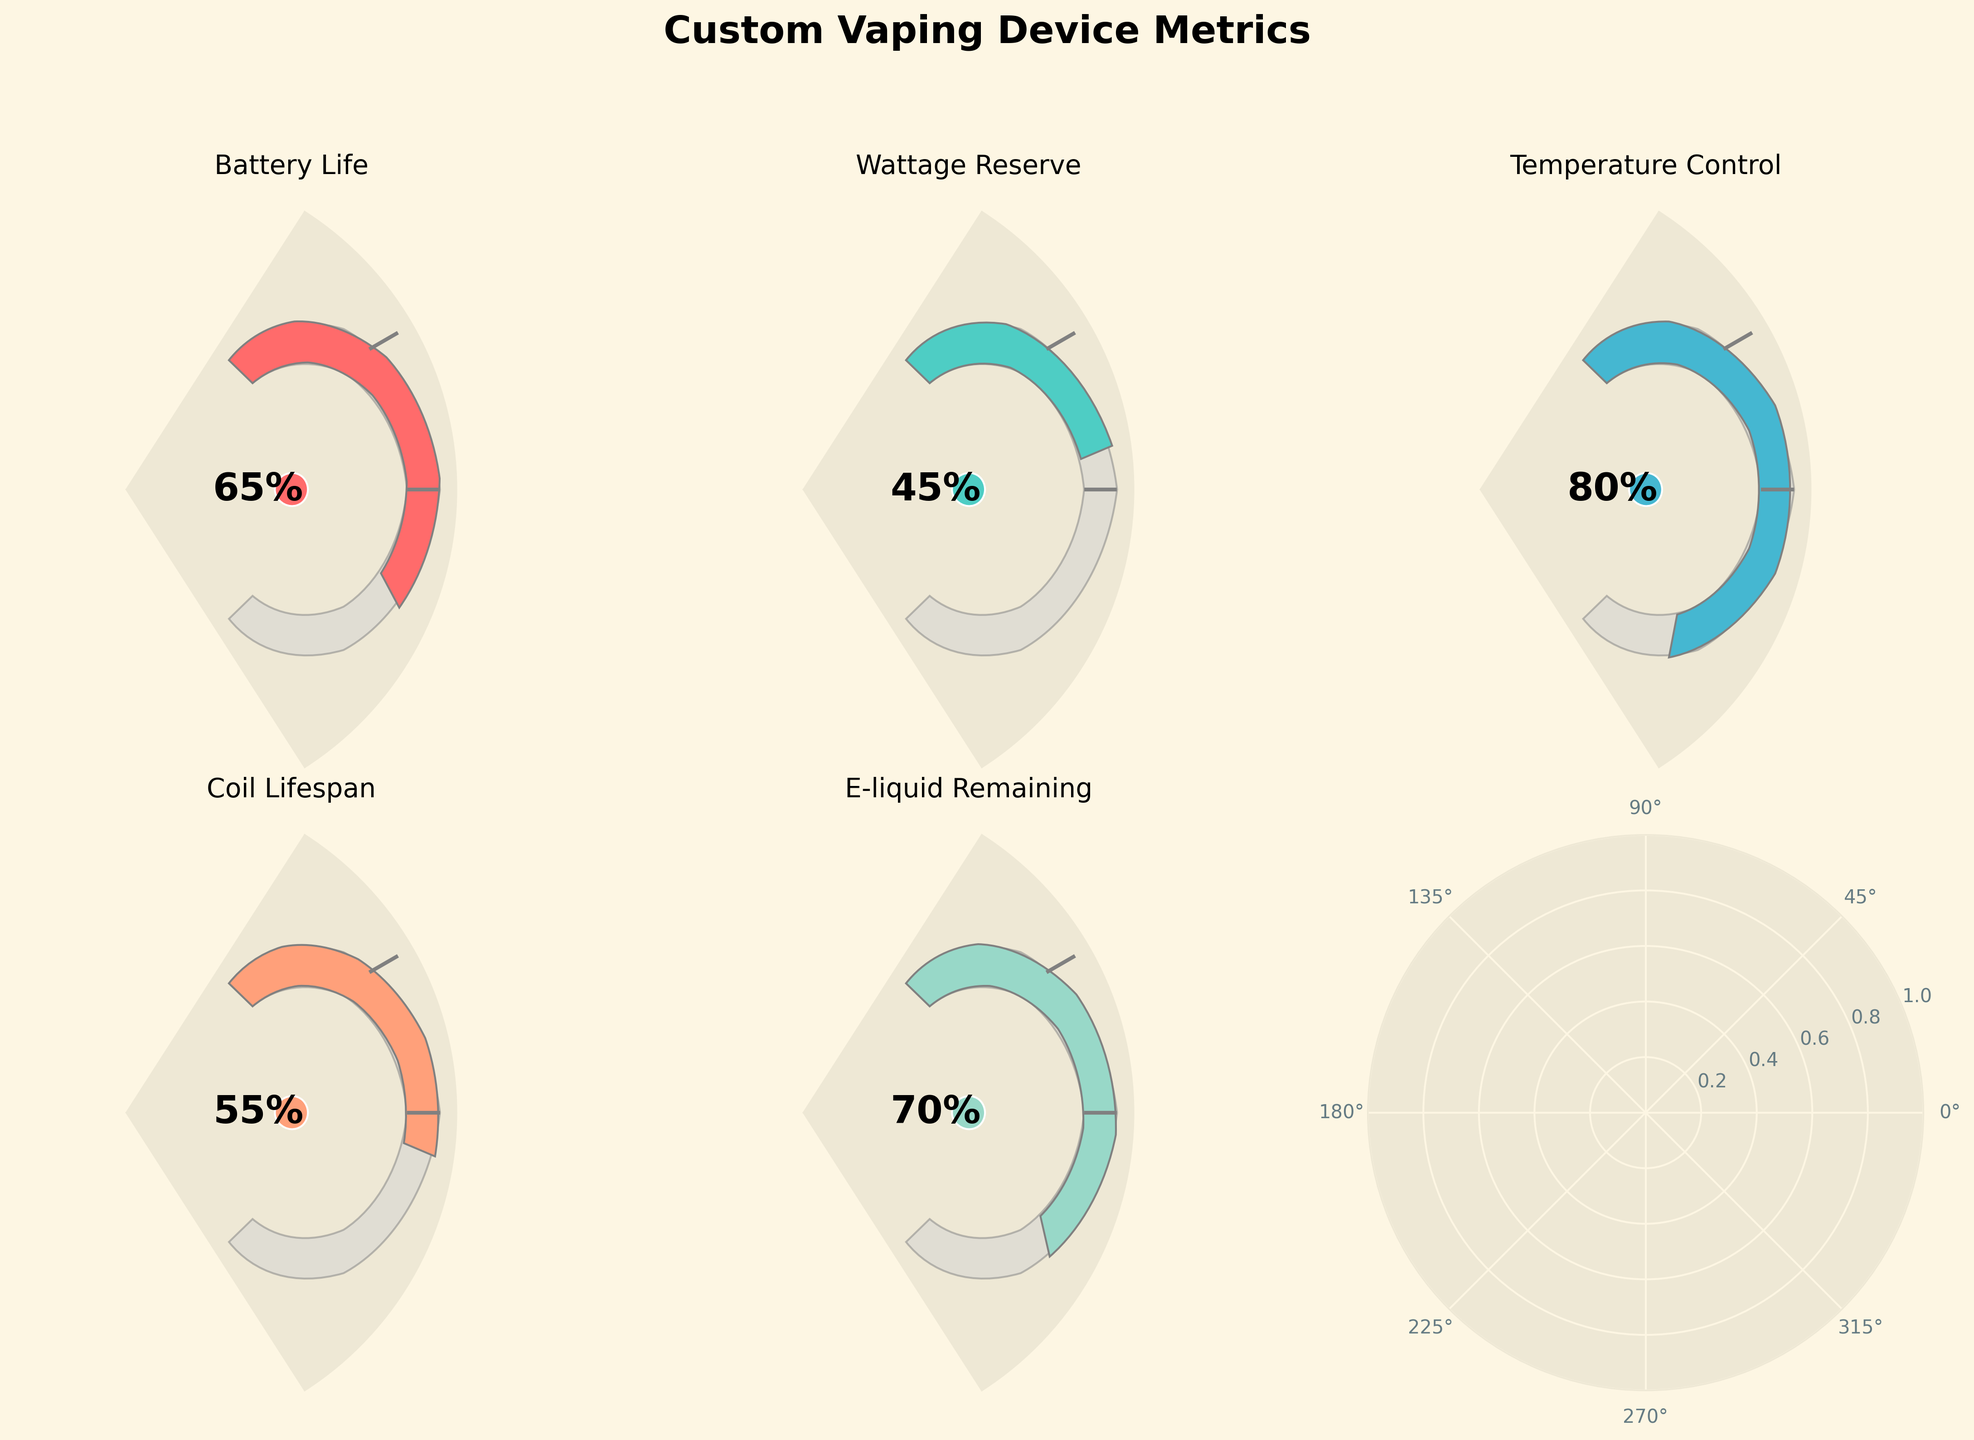What's the title of the figure? The title of the figure is displayed at the top center in bold letters: "Custom Vaping Device Metrics"
Answer: Custom Vaping Device Metrics What is the battery life percentage? To find the battery life percentage, look at the gauge labeled "Battery Life". The text within the gauge shows the value: it reads "65%".
Answer: 65% Which metric has the lowest value? Compare all the values in each of the gauges. "Wattage Reserve" shows the lowest with a value of "45%".
Answer: Wattage Reserve What is the difference between Coil Lifespan and E-liquid Remaining percentages? Coil Lifespan is 55% and E-liquid Remaining is 70%. The difference is 70 - 55 = 15
Answer: 15% How many metrics fall below 60%? Identify the metrics below 60%: Battery Life (65%), Wattage Reserve (45%), Temperature Control (80%), Coil Lifespan (55%), E-liquid Remaining (70%). Only "Wattage Reserve" and "Coil Lifespan" are below 60%. Thus, there are 2.
Answer: 2 Which metric is depicted with the most vibrant red color? The vibrant red color corresponds to "Battery Life", which is highlighted in red on the gauge.
Answer: Battery Life Are the gauges consistent in their scale? All gauges in the figure have the same maximum level of 100%. This consistency can be verified by checking all metrics share the same endpoint.
Answer: Yes Which metric shows an angle closest to half the gauge? To be closest to half the gauge, the value should be around 50%. "Coil Lifespan" at 55% is closest to half the 180-degree gauge.
Answer: Coil Lifespan What color represents the "Temperature Control" metric? Look at the color used in the "Temperature Control" gauge at 80%. It is represented by a blue-green color.
Answer: Blue-green Calculate the average battery level across all metrics and compare it to the "Battery Life" percentage. The sum of all percentages is: 65 + 45 + 80 + 55 + 70 = 315. The number of metrics is 5. The average is 315 / 5 = 63%. The "Battery Life" percentage is 65%, which is 2% higher than the average.
Answer: 2% higher 